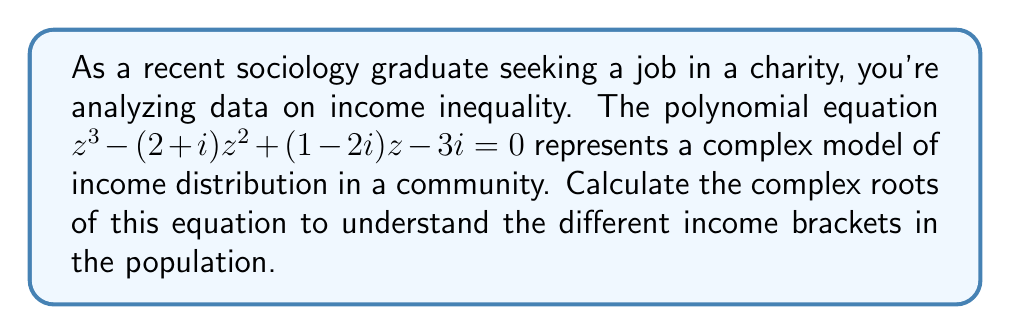Could you help me with this problem? To find the complex roots of the polynomial equation $z^3 - (2+i)z^2 + (1-2i)z - 3i = 0$, we'll use the cubic formula and complex number operations.

Step 1: Identify the coefficients
$a = 1$
$b = -(2+i)$
$c = 1-2i$
$d = -3i$

Step 2: Calculate auxiliary values
$p = \frac{3ac-b^2}{3a^2} = \frac{3(1)(1-2i)-(-2-i)^2}{3(1)^2} = \frac{3-6i-5-4i+1}{3} = -\frac{1+10i}{3}$

$q = \frac{2b^3-9abc+27a^2d}{27a^3} = \frac{2(-2-i)^3-9(1)(-2-i)(1-2i)+27(1)^2(-3i)}{27(1)^3}$
$= \frac{-16-24i+12-9i-18-9i+18i-36-81i}{27} = -2-4i$

Step 3: Calculate the discriminant
$D = (\frac{q}{2})^2 + (\frac{p}{3})^3 = (-1-2i)^2 + (-\frac{1}{3}-\frac{10i}{9})^3$
$= 1+4i-4 + (-\frac{1}{27}-\frac{10i}{27}-\frac{100}{27}+\frac{1000i}{243})$
$= -3+4i-\frac{101}{27}+\frac{838i}{243} \approx -6.74+7.45i$

Step 4: Calculate the cube roots
$u = \sqrt[3]{-\frac{q}{2} + \sqrt{D}} \approx 1.20+0.80i$
$v = \sqrt[3]{-\frac{q}{2} - \sqrt{D}} \approx -0.87-1.16i$

Step 5: Calculate the roots
$z_1 = u + v - \frac{b}{3a} \approx 1.20+0.80i-0.87-1.16i+\frac{2+i}{3} \approx 1.00+0.31i$
$z_2 = \omega u + \omega^2 v - \frac{b}{3a}$, where $\omega = -\frac{1}{2}+\frac{\sqrt{3}}{2}i$
$z_3 = \omega^2 u + \omega v - \frac{b}{3a}$, where $\omega^2 = -\frac{1}{2}-\frac{\sqrt{3}}{2}i$

Calculating $z_2$ and $z_3$:
$z_2 \approx 0.50-1.65i$
$z_3 \approx 0.50+1.34i$
Answer: $z_1 \approx 1.00+0.31i$, $z_2 \approx 0.50-1.65i$, $z_3 \approx 0.50+1.34i$ 